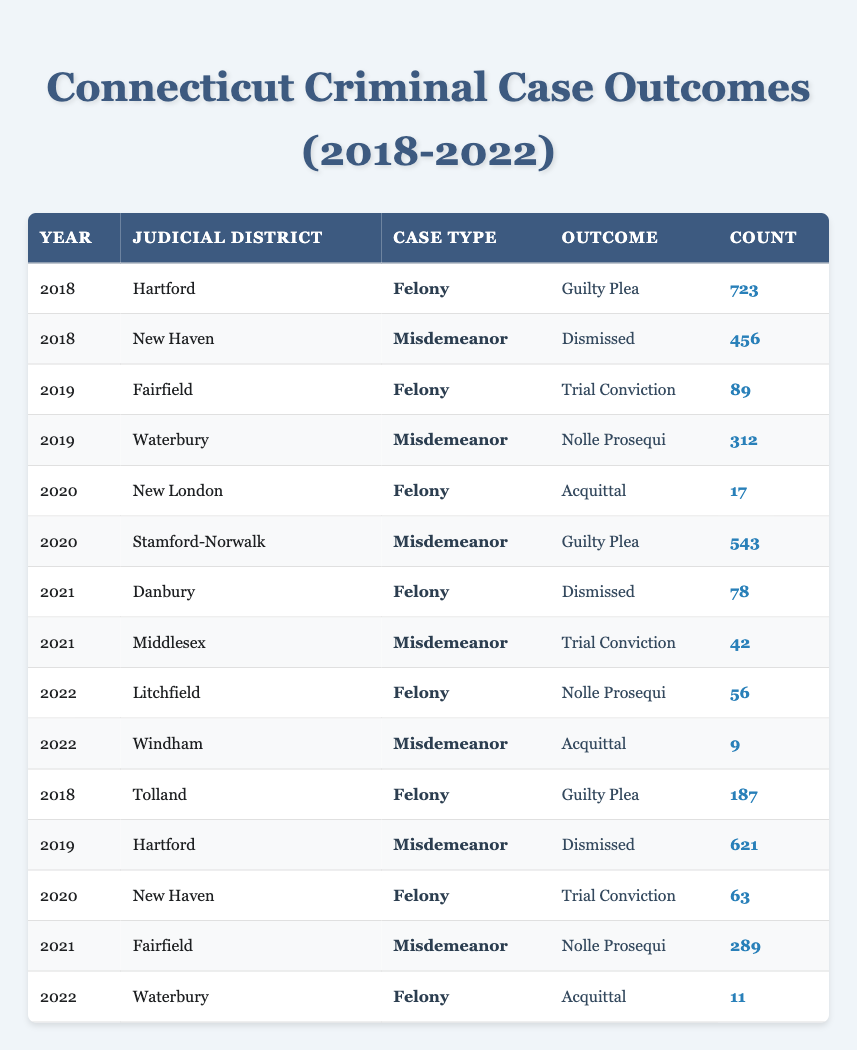What was the total count of guilty pleas for felonies in Hartford in 2018? In 2018, Hartford had a count of 723 for the outcome "Guilty Plea" under the case type "Felony." Therefore, the total count of guilty pleas for felonies in Hartford in 2018 is simply 723.
Answer: 723 How many cases were dismissed in Hartford in 2019? In 2019, there are two entries related to Hartford: one for Felony with a Guilty Plea and one for Misdemeanor with a Dismissed outcome. The count for the dismissed Misdemeanor case in Hartford is 621.
Answer: 621 What is the percentage of acquittals among the total felony cases reported in New London from 2018 to 2022? The only entry for New London is in 2020 with an Acquittal count of 17 and there are no other felony cases reported for this district, making the total felony count 17. Therefore, the percentage of acquittals is (17/17) * 100 = 100%.
Answer: 100% Which judicial district had the highest count of misdemeanor cases dismissed in 2018? Looking at the table for 2018, Hartford had a count of 621 for Dismissed Misdemeanor cases, while New Haven had a count of 456. Comparing these values shows Hartford had the highest count of dismissed misdemeanor cases in 2018.
Answer: Hartford In 2021, how many felony cases were dismissed in Danbury and how many misdemeanor cases were nolle prosequi in Fairfield? In 2021, Danbury had a count of 78 for Dismissed felony cases, while Fairfield had 289 misdemeanor cases with a Nolle Prosequi outcome. The two cases add up to 367.
Answer: 367 Did any judicial district have an acquittal outcome for misdemeanors in the years represented? Upon checking all entries in the table, there are no cases listed under Acquittal for misdemeanor outcomes in any judicial district. Thus, the answer is no.
Answer: No What was the total count of guilty pleas in Stamford-Norwalk in 2020, and how does it compare to the total count of trials in 2019 in Fairfield? In 2020, Stamford-Norwalk had a count of 543 for Guilty Pleas under Misdemeanor. In 2019, Fairfield had a Trial Conviction count of 89. Comparing these values, 543 is significantly greater than 89.
Answer: 543; greater Is there any judicial district where the count of felony cases for the outcome “Acquittal” exceeded 20? The only Acquittal listed in the table is from New London with a count of 17. All other entries for Acquittals in felony cases do not exceed 20. Thus, the answer is no.
Answer: No What is the trend observed in the outcomes for felony cases in Waterbury over the years? In reviewing the data, Waterbury only shows one entry for a felony case in 2022 with an Acquittal count of 11. Consequently, no trend can be assessed since no previous years and outcomes are presented.
Answer: Not enough data 